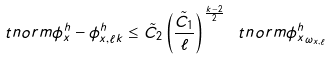Convert formula to latex. <formula><loc_0><loc_0><loc_500><loc_500>\ t n o r m { \phi ^ { h } _ { x } - \phi ^ { h } _ { x , \ell k } } \leq \tilde { C } _ { 2 } \left ( \frac { \tilde { C } _ { 1 } } { \ell } \right ) ^ { \frac { k - 2 } { 2 } } \ t n o r m { \phi ^ { h } _ { x } } _ { \omega _ { x , \ell } }</formula> 